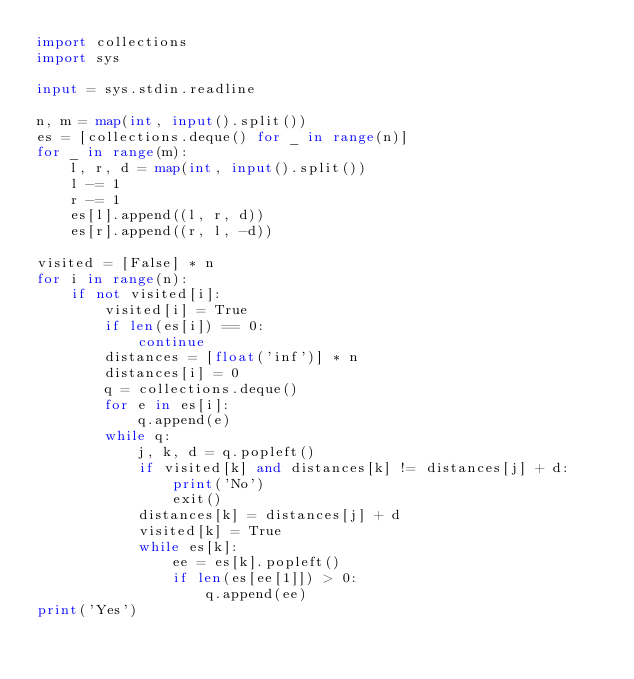<code> <loc_0><loc_0><loc_500><loc_500><_Python_>import collections
import sys

input = sys.stdin.readline

n, m = map(int, input().split())
es = [collections.deque() for _ in range(n)]
for _ in range(m):
    l, r, d = map(int, input().split())
    l -= 1
    r -= 1
    es[l].append((l, r, d))
    es[r].append((r, l, -d))

visited = [False] * n
for i in range(n):
    if not visited[i]:
        visited[i] = True
        if len(es[i]) == 0:
            continue
        distances = [float('inf')] * n
        distances[i] = 0
        q = collections.deque()
        for e in es[i]:
            q.append(e)
        while q:
            j, k, d = q.popleft()
            if visited[k] and distances[k] != distances[j] + d:
                print('No')
                exit()
            distances[k] = distances[j] + d
            visited[k] = True
            while es[k]:
                ee = es[k].popleft()
                if len(es[ee[1]]) > 0:
                    q.append(ee)
print('Yes')</code> 